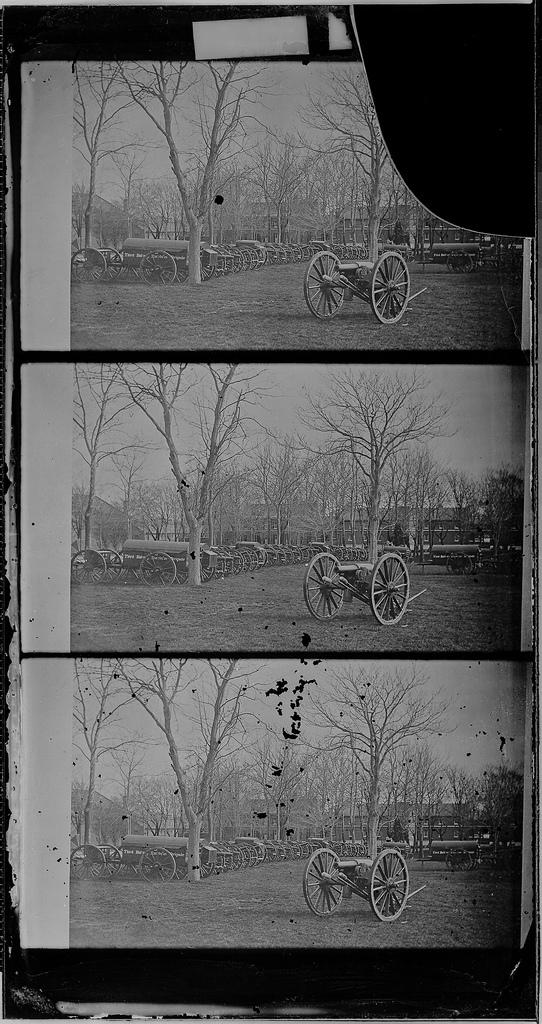What type of images are included in the collage in the image? The collage contains black and white pictures. What subjects are depicted in the collage? Vehicles and a group of trees are depicted in the collage. What part of the natural environment is visible in the collage? The sky is visible in the collage. Can you tell me how many cubs are playing with scissors in the collage? There are no cubs or scissors present in the collage; it features black and white pictures of vehicles and a group of trees. What type of leg is visible in the collage? There is no leg visible in the collage; it only contains pictures of vehicles, trees, and the sky. 